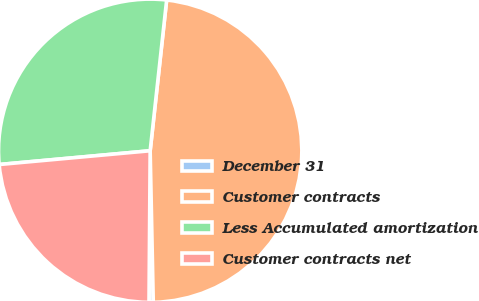<chart> <loc_0><loc_0><loc_500><loc_500><pie_chart><fcel>December 31<fcel>Customer contracts<fcel>Less Accumulated amortization<fcel>Customer contracts net<nl><fcel>0.45%<fcel>47.94%<fcel>28.18%<fcel>23.43%<nl></chart> 